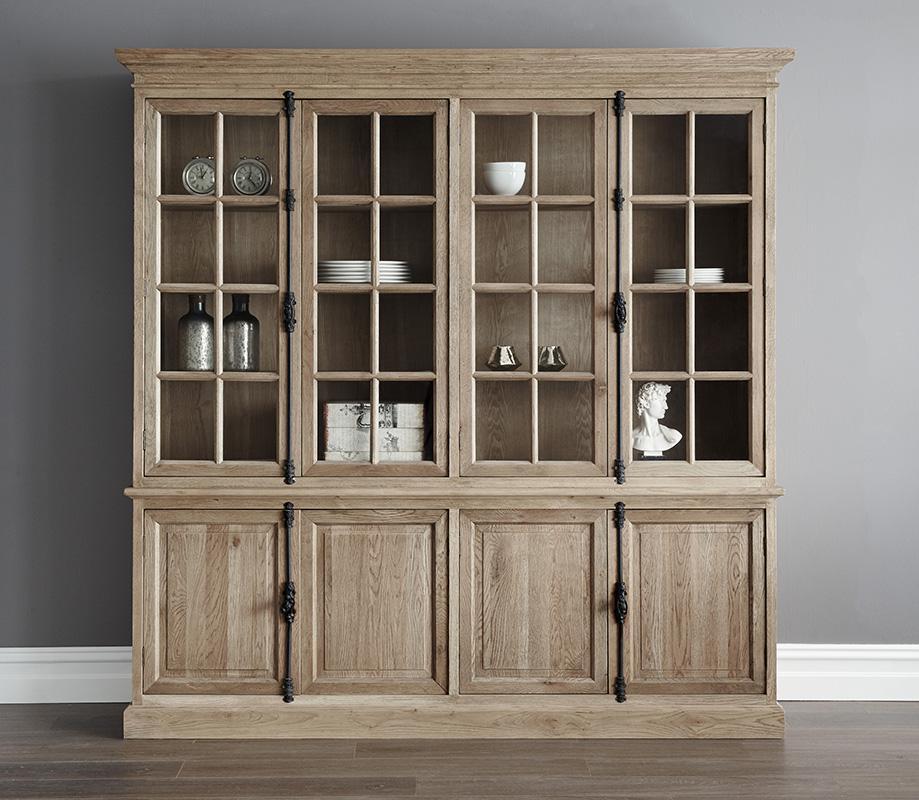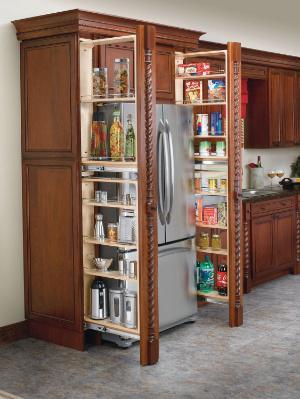The first image is the image on the left, the second image is the image on the right. For the images displayed, is the sentence "A bookcase in one image has upper glass doors with panes, over a solid lower section." factually correct? Answer yes or no. Yes. 